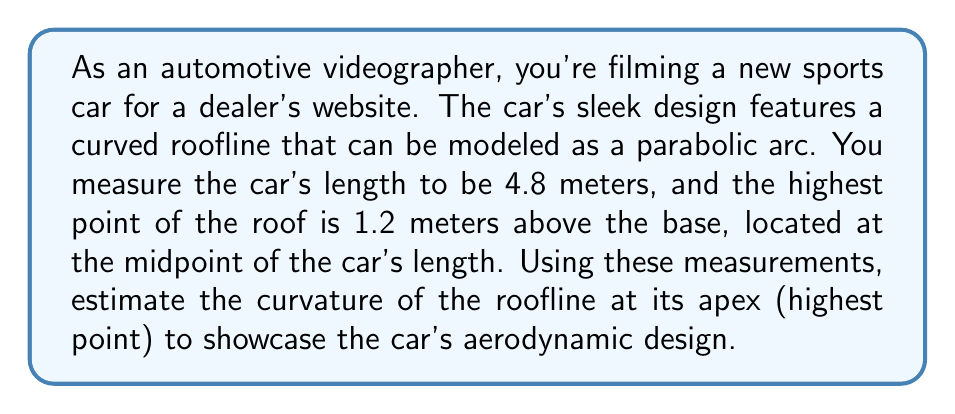Can you answer this question? To solve this problem, we'll follow these steps:

1) The parabola that models the roofline can be described by the equation:
   $$y = a(x - h)^2 + k$$
   where $(h, k)$ is the vertex of the parabola.

2) We know that:
   - The length of the car is 4.8 meters, so the x-axis goes from 0 to 4.8.
   - The highest point (vertex) is at the midpoint, so $h = 2.4$ meters.
   - The height of the roof at this point is 1.2 meters, so $k = 1.2$.

3) We can find $a$ by using a point on the parabola. At $x = 0$ (or $x = 4.8$), $y = 0$:
   $$0 = a(0 - 2.4)^2 + 1.2$$
   $$-1.2 = a(5.76)$$
   $$a = -\frac{1.2}{5.76} = -\frac{5}{24}$$

4) Now we have the equation of the parabola:
   $$y = -\frac{5}{24}(x - 2.4)^2 + 1.2$$

5) The curvature $\kappa$ of a parabola $y = ax^2 + bx + c$ at any point is given by:
   $$\kappa = \frac{|2a|}{(1 + (2ax + b)^2)^{3/2}}$$

6) At the vertex $(h, k)$, this simplifies to:
   $$\kappa = |2a|$$

7) In our case, $a = -\frac{5}{24}$, so:
   $$\kappa = \left|2 \cdot \left(-\frac{5}{24}\right)\right| = \frac{5}{12} \approx 0.4167\text{ m}^{-1}$$

This curvature value represents the reciprocal of the radius of the osculating circle at the apex of the roofline.
Answer: The estimated curvature of the car's roofline at its apex is $\frac{5}{12} \approx 0.4167\text{ m}^{-1}$. 